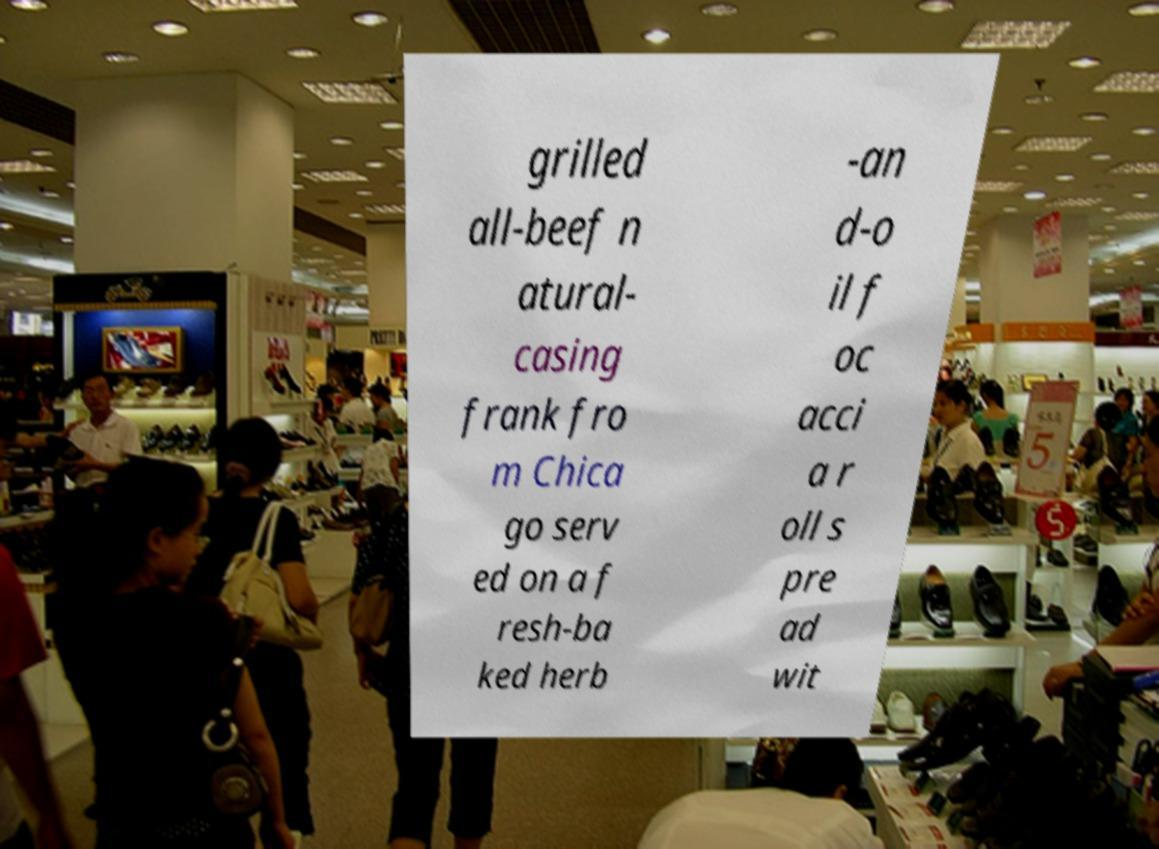Can you accurately transcribe the text from the provided image for me? grilled all-beef n atural- casing frank fro m Chica go serv ed on a f resh-ba ked herb -an d-o il f oc acci a r oll s pre ad wit 